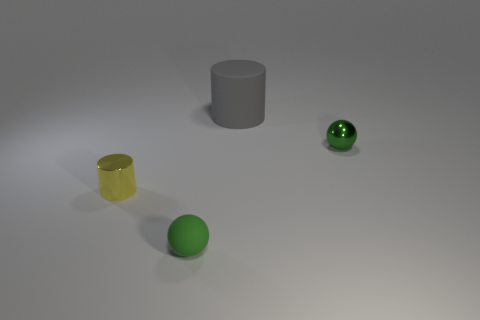Add 1 objects. How many objects exist? 5 Subtract all gray cylinders. How many cylinders are left? 1 Subtract 0 purple blocks. How many objects are left? 4 Subtract 1 balls. How many balls are left? 1 Subtract all yellow balls. Subtract all green cylinders. How many balls are left? 2 Subtract all gray cubes. How many yellow cylinders are left? 1 Subtract all large gray cylinders. Subtract all large rubber cylinders. How many objects are left? 2 Add 3 big cylinders. How many big cylinders are left? 4 Add 3 small green metal balls. How many small green metal balls exist? 4 